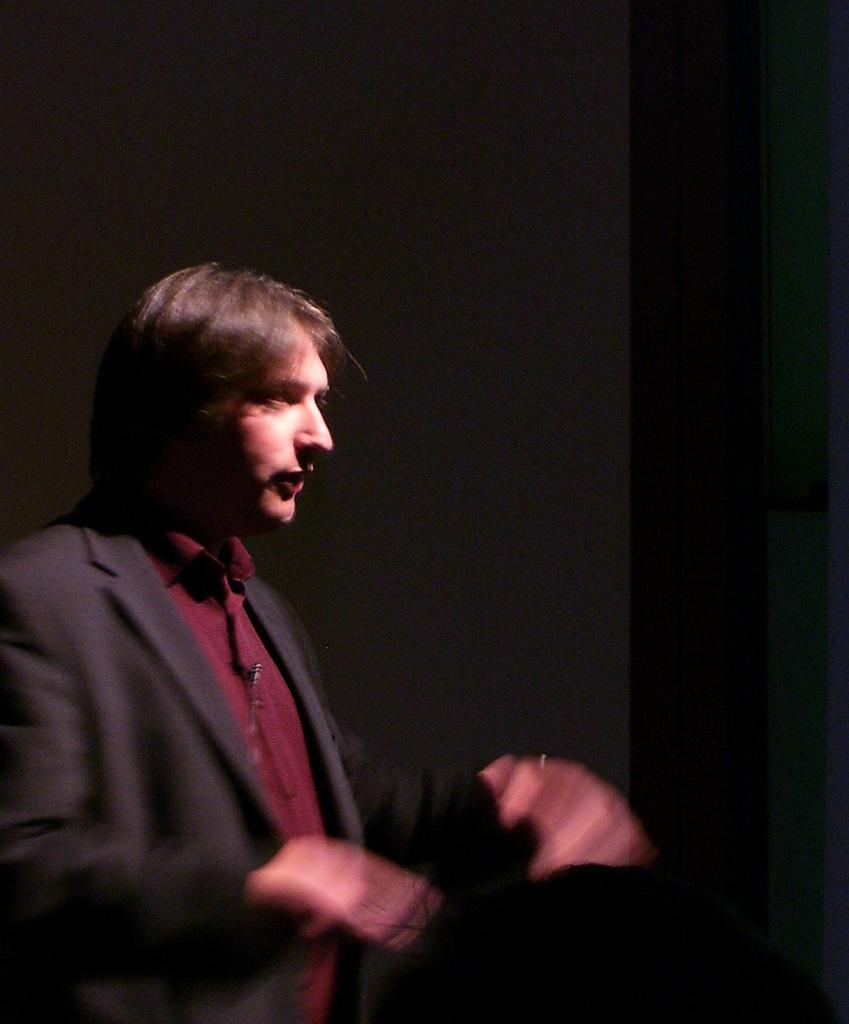What is the main subject of the image? There is a person standing in the image. Can you describe the background of the image? The background of the image is dark. What type of apparel is the person's partner wearing in the image? There is no partner present in the image, so it is not possible to answer that question. 